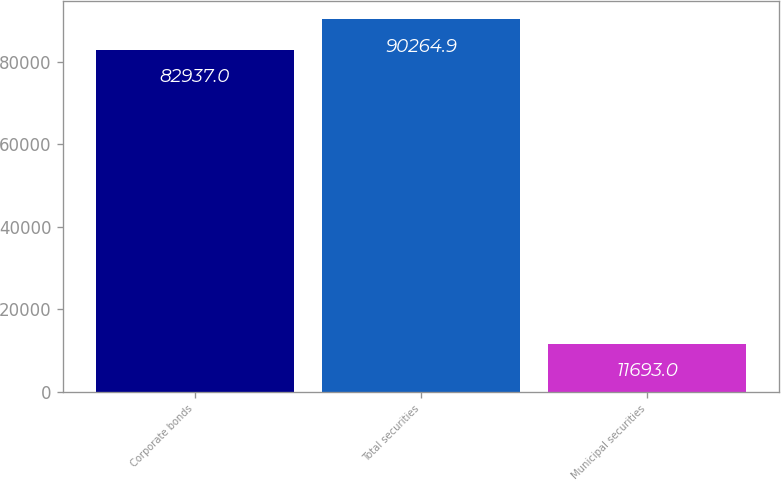Convert chart to OTSL. <chart><loc_0><loc_0><loc_500><loc_500><bar_chart><fcel>Corporate bonds<fcel>Total securities<fcel>Municipal securities<nl><fcel>82937<fcel>90264.9<fcel>11693<nl></chart> 